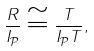Convert formula to latex. <formula><loc_0><loc_0><loc_500><loc_500>\frac { R } { I _ { \mathcal { P } } } \cong \frac { T } { I _ { \mathcal { P } } T } ,</formula> 